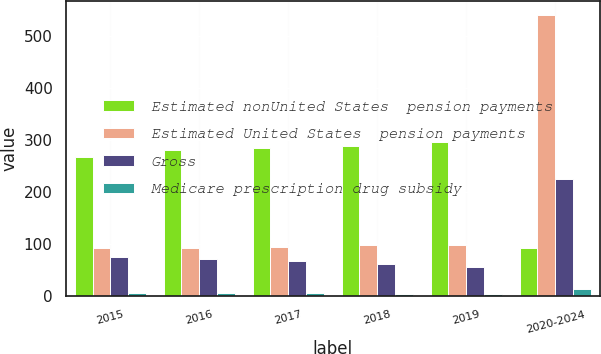Convert chart to OTSL. <chart><loc_0><loc_0><loc_500><loc_500><stacked_bar_chart><ecel><fcel>2015<fcel>2016<fcel>2017<fcel>2018<fcel>2019<fcel>2020-2024<nl><fcel>Estimated nonUnited States  pension payments<fcel>268<fcel>281<fcel>285<fcel>289<fcel>297<fcel>92<nl><fcel>Estimated United States  pension payments<fcel>92<fcel>92<fcel>94<fcel>98<fcel>99<fcel>542<nl><fcel>Gross<fcel>75<fcel>71<fcel>67<fcel>62<fcel>56<fcel>226<nl><fcel>Medicare prescription drug subsidy<fcel>6<fcel>6<fcel>6<fcel>5<fcel>4<fcel>13<nl></chart> 